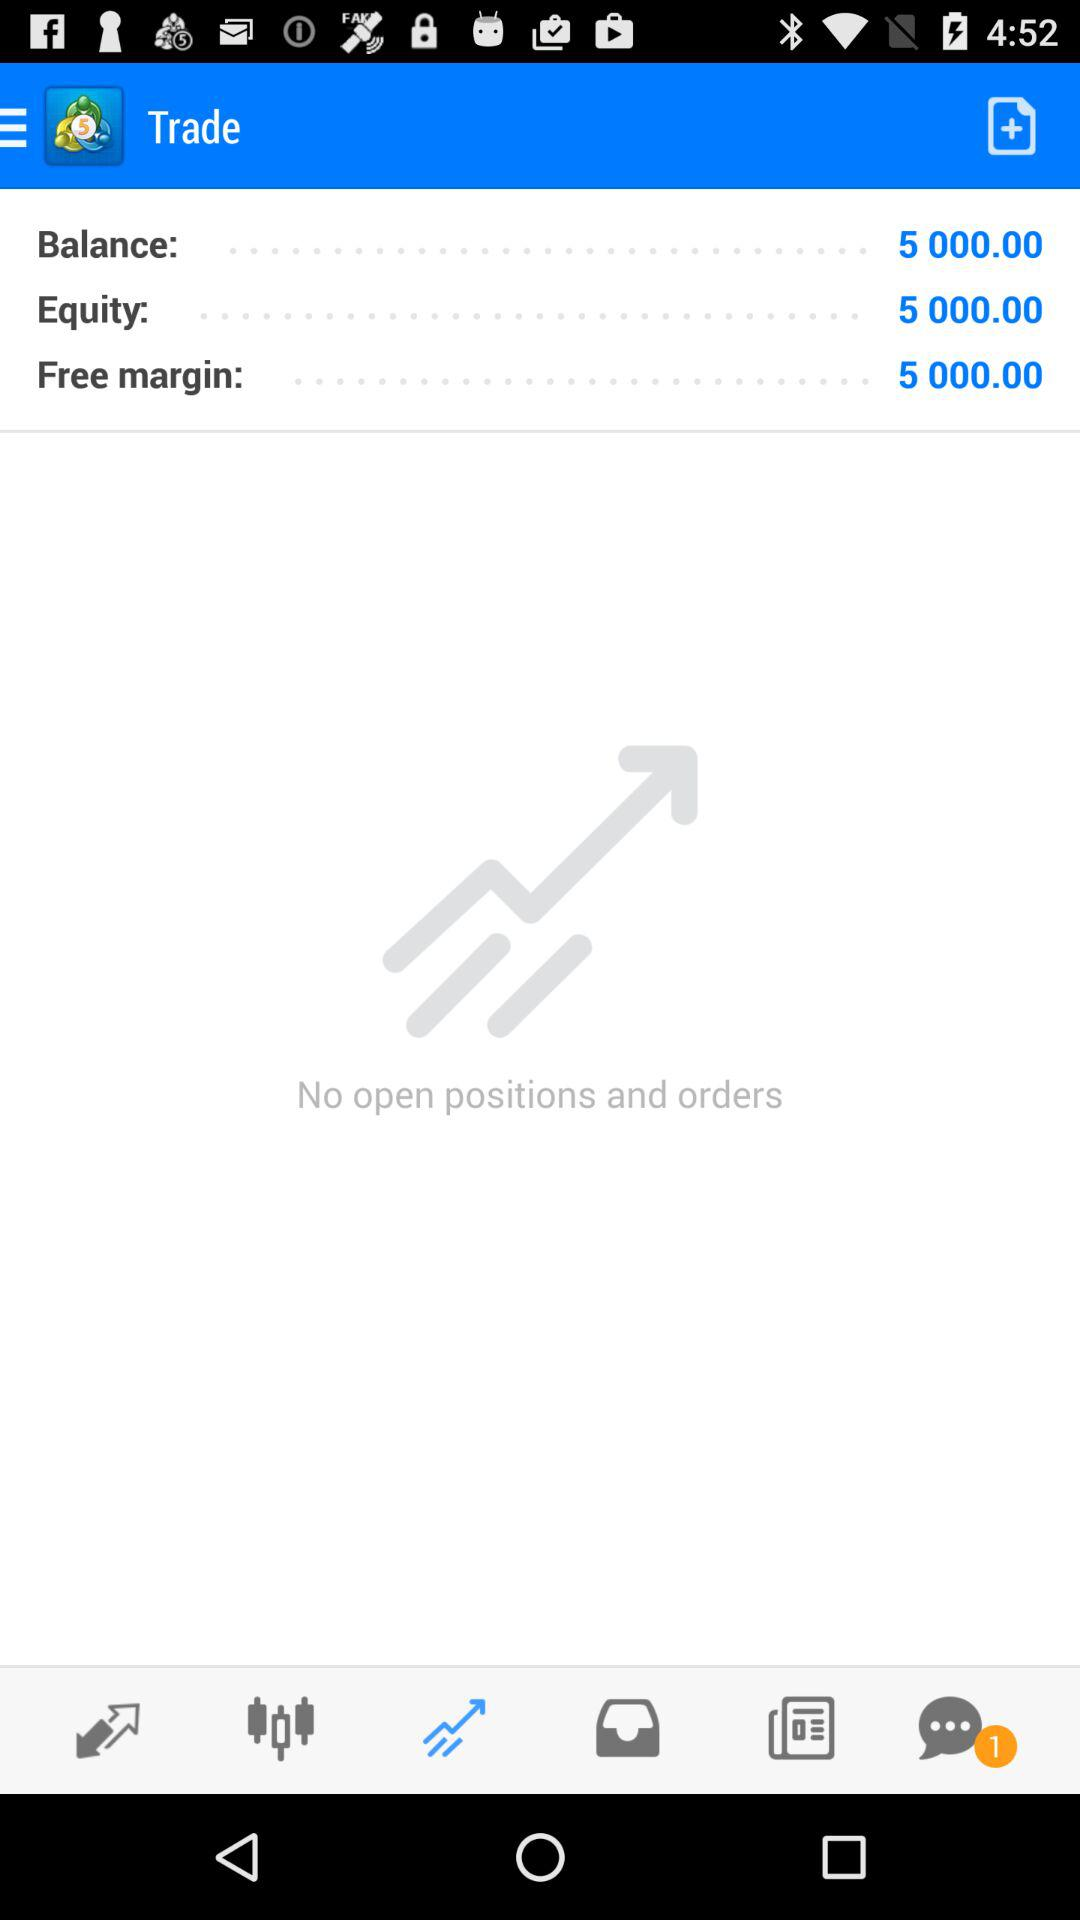How many open positions and orders does the user have?
Answer the question using a single word or phrase. 0 